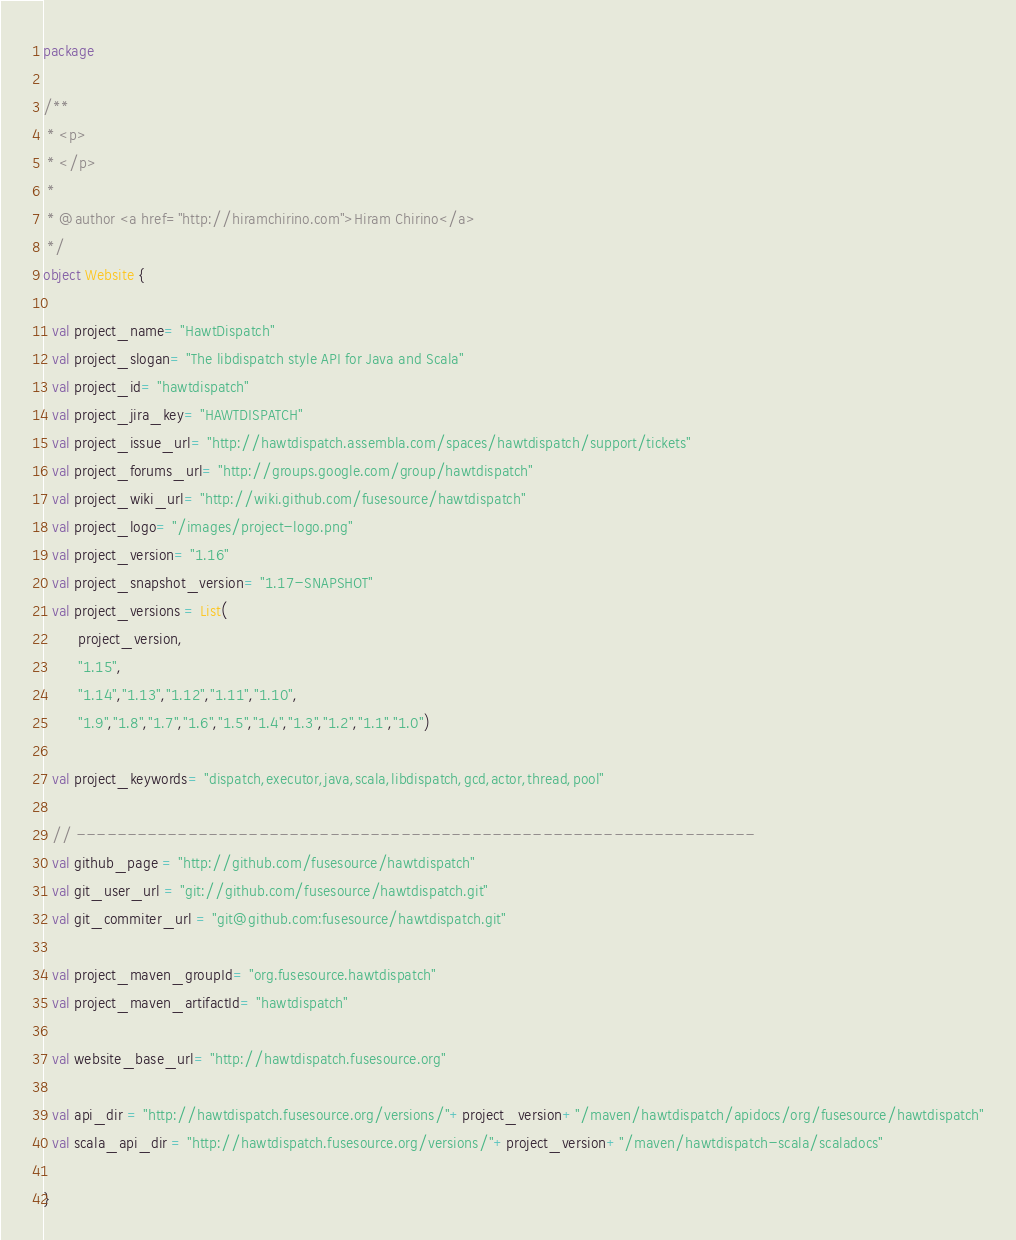<code> <loc_0><loc_0><loc_500><loc_500><_Scala_>package

/**
 * <p>
 * </p>
 *
 * @author <a href="http://hiramchirino.com">Hiram Chirino</a>
 */
object Website {

  val project_name= "HawtDispatch"
  val project_slogan= "The libdispatch style API for Java and Scala"
  val project_id= "hawtdispatch"
  val project_jira_key= "HAWTDISPATCH"
  val project_issue_url= "http://hawtdispatch.assembla.com/spaces/hawtdispatch/support/tickets"
  val project_forums_url= "http://groups.google.com/group/hawtdispatch"
  val project_wiki_url= "http://wiki.github.com/fusesource/hawtdispatch"
  val project_logo= "/images/project-logo.png"
  val project_version= "1.16"
  val project_snapshot_version= "1.17-SNAPSHOT"
  val project_versions = List(
        project_version,
        "1.15",
        "1.14","1.13","1.12","1.11","1.10",
        "1.9","1.8","1.7","1.6","1.5","1.4","1.3","1.2","1.1","1.0")  

  val project_keywords= "dispatch,executor,java,scala,libdispatch,gcd,actor,thread,pool"

  // -------------------------------------------------------------------
  val github_page = "http://github.com/fusesource/hawtdispatch"
  val git_user_url = "git://github.com/fusesource/hawtdispatch.git"
  val git_commiter_url = "git@github.com:fusesource/hawtdispatch.git"
  
  val project_maven_groupId= "org.fusesource.hawtdispatch"
  val project_maven_artifactId= "hawtdispatch"

  val website_base_url= "http://hawtdispatch.fusesource.org"
  
  val api_dir = "http://hawtdispatch.fusesource.org/versions/"+project_version+"/maven/hawtdispatch/apidocs/org/fusesource/hawtdispatch"
  val scala_api_dir = "http://hawtdispatch.fusesource.org/versions/"+project_version+"/maven/hawtdispatch-scala/scaladocs"

}</code> 